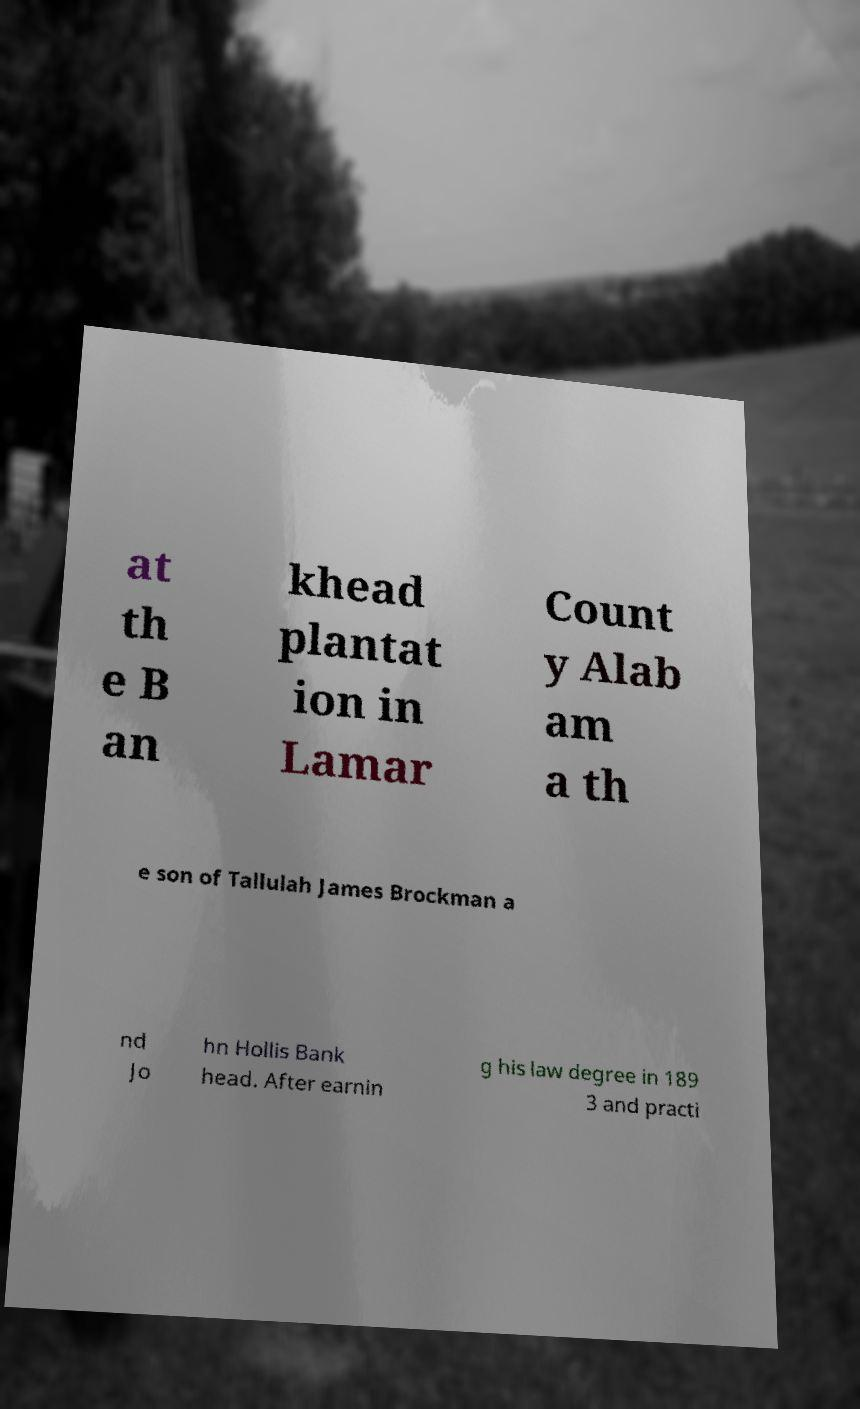Could you extract and type out the text from this image? at th e B an khead plantat ion in Lamar Count y Alab am a th e son of Tallulah James Brockman a nd Jo hn Hollis Bank head. After earnin g his law degree in 189 3 and practi 